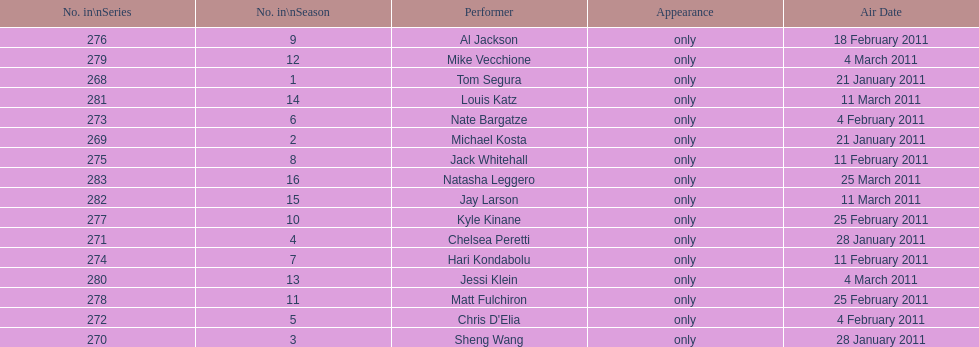How many performers appeared on the air date 21 january 2011? 2. 